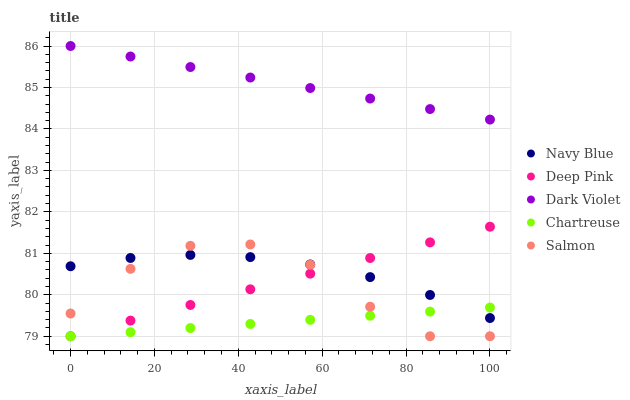Does Chartreuse have the minimum area under the curve?
Answer yes or no. Yes. Does Dark Violet have the maximum area under the curve?
Answer yes or no. Yes. Does Deep Pink have the minimum area under the curve?
Answer yes or no. No. Does Deep Pink have the maximum area under the curve?
Answer yes or no. No. Is Dark Violet the smoothest?
Answer yes or no. Yes. Is Salmon the roughest?
Answer yes or no. Yes. Is Chartreuse the smoothest?
Answer yes or no. No. Is Chartreuse the roughest?
Answer yes or no. No. Does Chartreuse have the lowest value?
Answer yes or no. Yes. Does Dark Violet have the lowest value?
Answer yes or no. No. Does Dark Violet have the highest value?
Answer yes or no. Yes. Does Deep Pink have the highest value?
Answer yes or no. No. Is Salmon less than Dark Violet?
Answer yes or no. Yes. Is Dark Violet greater than Chartreuse?
Answer yes or no. Yes. Does Deep Pink intersect Salmon?
Answer yes or no. Yes. Is Deep Pink less than Salmon?
Answer yes or no. No. Is Deep Pink greater than Salmon?
Answer yes or no. No. Does Salmon intersect Dark Violet?
Answer yes or no. No. 